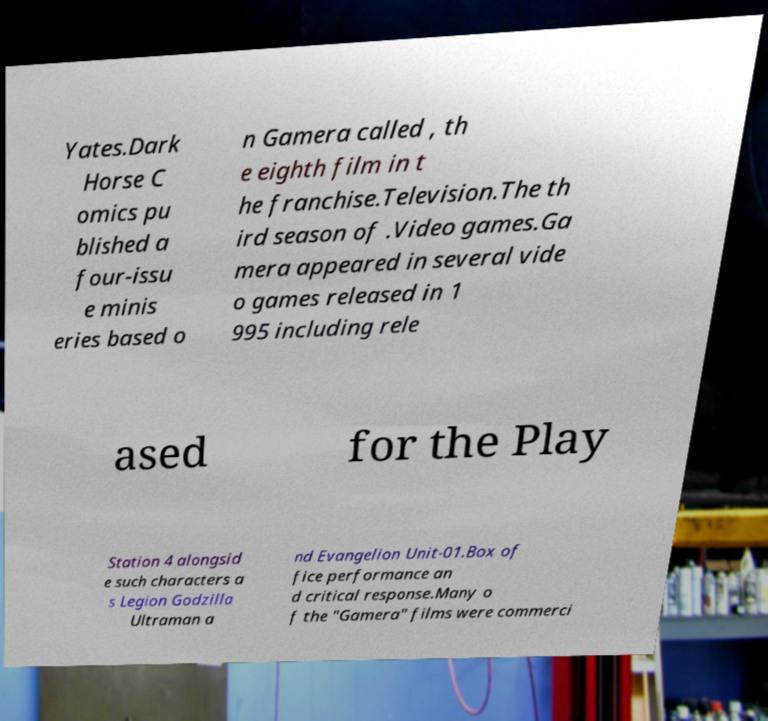I need the written content from this picture converted into text. Can you do that? Yates.Dark Horse C omics pu blished a four-issu e minis eries based o n Gamera called , th e eighth film in t he franchise.Television.The th ird season of .Video games.Ga mera appeared in several vide o games released in 1 995 including rele ased for the Play Station 4 alongsid e such characters a s Legion Godzilla Ultraman a nd Evangelion Unit-01.Box of fice performance an d critical response.Many o f the "Gamera" films were commerci 